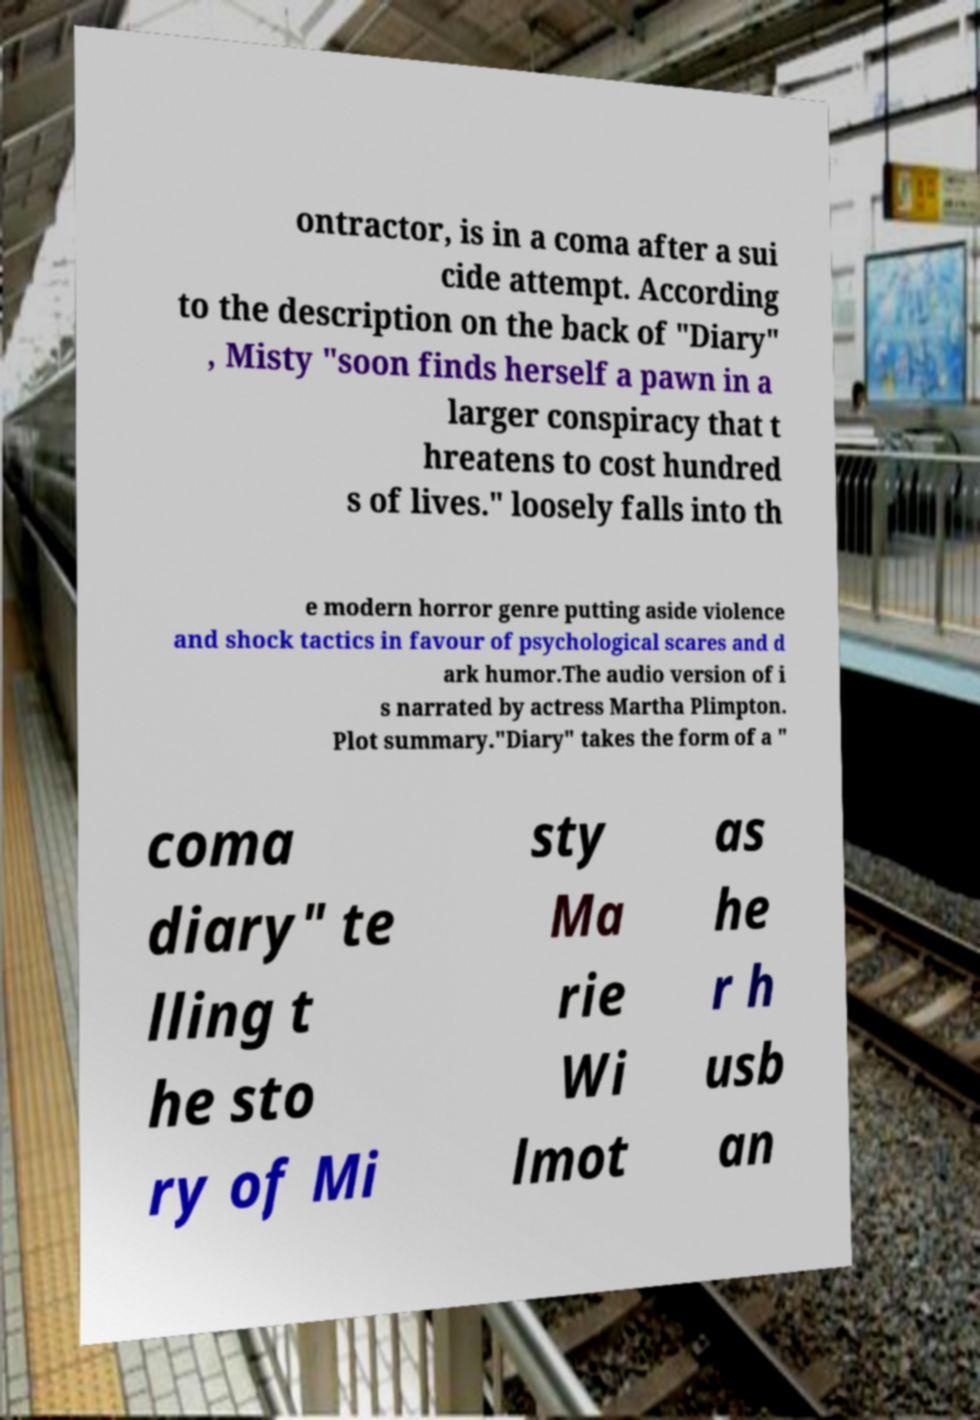What messages or text are displayed in this image? I need them in a readable, typed format. ontractor, is in a coma after a sui cide attempt. According to the description on the back of "Diary" , Misty "soon finds herself a pawn in a larger conspiracy that t hreatens to cost hundred s of lives." loosely falls into th e modern horror genre putting aside violence and shock tactics in favour of psychological scares and d ark humor.The audio version of i s narrated by actress Martha Plimpton. Plot summary."Diary" takes the form of a " coma diary" te lling t he sto ry of Mi sty Ma rie Wi lmot as he r h usb an 